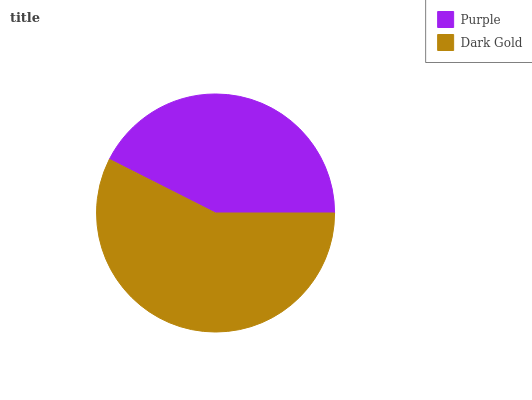Is Purple the minimum?
Answer yes or no. Yes. Is Dark Gold the maximum?
Answer yes or no. Yes. Is Dark Gold the minimum?
Answer yes or no. No. Is Dark Gold greater than Purple?
Answer yes or no. Yes. Is Purple less than Dark Gold?
Answer yes or no. Yes. Is Purple greater than Dark Gold?
Answer yes or no. No. Is Dark Gold less than Purple?
Answer yes or no. No. Is Dark Gold the high median?
Answer yes or no. Yes. Is Purple the low median?
Answer yes or no. Yes. Is Purple the high median?
Answer yes or no. No. Is Dark Gold the low median?
Answer yes or no. No. 